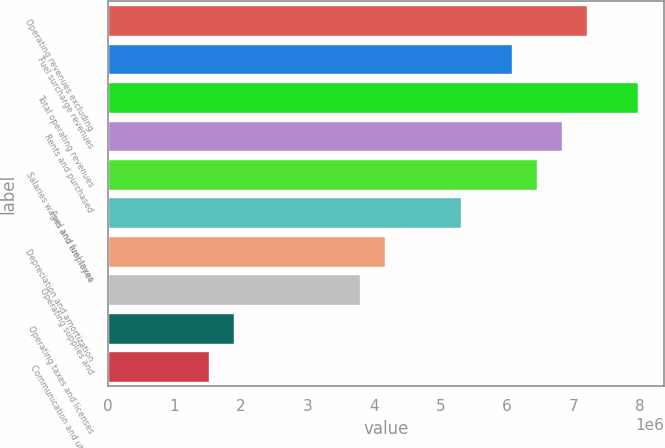<chart> <loc_0><loc_0><loc_500><loc_500><bar_chart><fcel>Operating revenues excluding<fcel>Fuel surcharge revenues<fcel>Total operating revenues<fcel>Rents and purchased<fcel>Salaries wages and employee<fcel>Fuel and fuel taxes<fcel>Depreciation and amortization<fcel>Operating supplies and<fcel>Operating taxes and licenses<fcel>Communication and utilities<nl><fcel>7.20762e+06<fcel>6.06958e+06<fcel>7.96632e+06<fcel>6.82827e+06<fcel>6.44892e+06<fcel>5.31088e+06<fcel>4.17283e+06<fcel>3.79348e+06<fcel>1.89674e+06<fcel>1.51739e+06<nl></chart> 